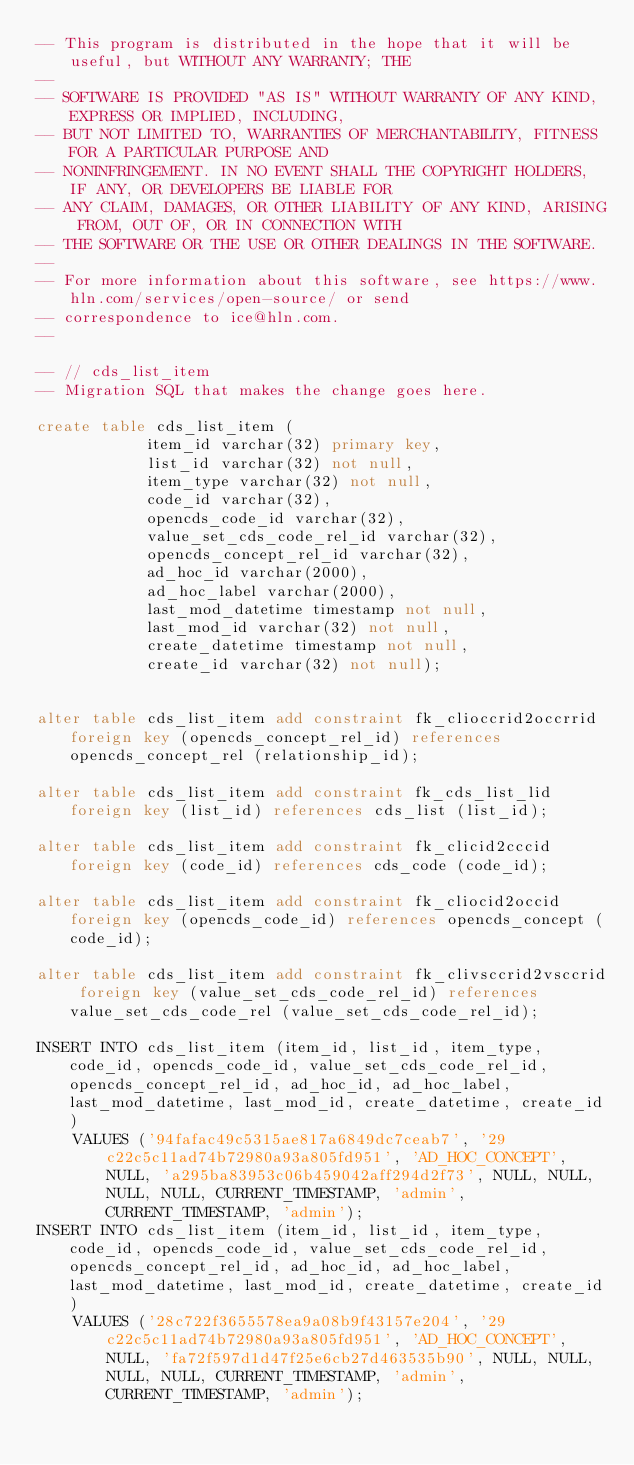Convert code to text. <code><loc_0><loc_0><loc_500><loc_500><_SQL_>-- This program is distributed in the hope that it will be useful, but WITHOUT ANY WARRANTY; THE
--
-- SOFTWARE IS PROVIDED "AS IS" WITHOUT WARRANTY OF ANY KIND, EXPRESS OR IMPLIED, INCLUDING,
-- BUT NOT LIMITED TO, WARRANTIES OF MERCHANTABILITY, FITNESS FOR A PARTICULAR PURPOSE AND
-- NONINFRINGEMENT. IN NO EVENT SHALL THE COPYRIGHT HOLDERS, IF ANY, OR DEVELOPERS BE LIABLE FOR
-- ANY CLAIM, DAMAGES, OR OTHER LIABILITY OF ANY KIND, ARISING FROM, OUT OF, OR IN CONNECTION WITH
-- THE SOFTWARE OR THE USE OR OTHER DEALINGS IN THE SOFTWARE.
--
-- For more information about this software, see https://www.hln.com/services/open-source/ or send
-- correspondence to ice@hln.com.
--

-- // cds_list_item
-- Migration SQL that makes the change goes here.

create table cds_list_item (
            item_id varchar(32) primary key,
            list_id varchar(32) not null,
            item_type varchar(32) not null,
            code_id varchar(32),
            opencds_code_id varchar(32),
            value_set_cds_code_rel_id varchar(32),
            opencds_concept_rel_id varchar(32),
            ad_hoc_id varchar(2000),
            ad_hoc_label varchar(2000),
            last_mod_datetime timestamp not null,
            last_mod_id varchar(32) not null,
            create_datetime timestamp not null,
            create_id varchar(32) not null);


alter table cds_list_item add constraint fk_clioccrid2occrrid foreign key (opencds_concept_rel_id) references opencds_concept_rel (relationship_id);

alter table cds_list_item add constraint fk_cds_list_lid foreign key (list_id) references cds_list (list_id);

alter table cds_list_item add constraint fk_clicid2cccid foreign key (code_id) references cds_code (code_id);

alter table cds_list_item add constraint fk_cliocid2occid foreign key (opencds_code_id) references opencds_concept (code_id);

alter table cds_list_item add constraint fk_clivsccrid2vsccrid foreign key (value_set_cds_code_rel_id) references value_set_cds_code_rel (value_set_cds_code_rel_id);

INSERT INTO cds_list_item (item_id, list_id, item_type, code_id, opencds_code_id, value_set_cds_code_rel_id, opencds_concept_rel_id, ad_hoc_id, ad_hoc_label, last_mod_datetime, last_mod_id, create_datetime, create_id) 
    VALUES ('94fafac49c5315ae817a6849dc7ceab7', '29c22c5c11ad74b72980a93a805fd951', 'AD_HOC_CONCEPT', NULL, 'a295ba83953c06b459042aff294d2f73', NULL, NULL, NULL, NULL, CURRENT_TIMESTAMP, 'admin', CURRENT_TIMESTAMP, 'admin');
INSERT INTO cds_list_item (item_id, list_id, item_type, code_id, opencds_code_id, value_set_cds_code_rel_id, opencds_concept_rel_id, ad_hoc_id, ad_hoc_label, last_mod_datetime, last_mod_id, create_datetime, create_id) 
    VALUES ('28c722f3655578ea9a08b9f43157e204', '29c22c5c11ad74b72980a93a805fd951', 'AD_HOC_CONCEPT', NULL, 'fa72f597d1d47f25e6cb27d463535b90', NULL, NULL, NULL, NULL, CURRENT_TIMESTAMP, 'admin', CURRENT_TIMESTAMP, 'admin');</code> 